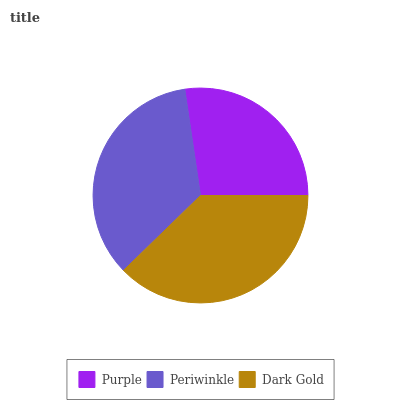Is Purple the minimum?
Answer yes or no. Yes. Is Dark Gold the maximum?
Answer yes or no. Yes. Is Periwinkle the minimum?
Answer yes or no. No. Is Periwinkle the maximum?
Answer yes or no. No. Is Periwinkle greater than Purple?
Answer yes or no. Yes. Is Purple less than Periwinkle?
Answer yes or no. Yes. Is Purple greater than Periwinkle?
Answer yes or no. No. Is Periwinkle less than Purple?
Answer yes or no. No. Is Periwinkle the high median?
Answer yes or no. Yes. Is Periwinkle the low median?
Answer yes or no. Yes. Is Dark Gold the high median?
Answer yes or no. No. Is Purple the low median?
Answer yes or no. No. 